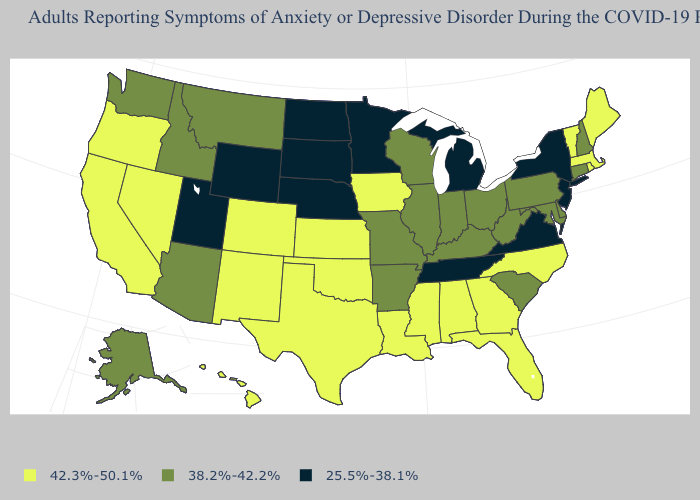What is the value of Ohio?
Quick response, please. 38.2%-42.2%. Does Delaware have the highest value in the USA?
Answer briefly. No. What is the value of Maryland?
Concise answer only. 38.2%-42.2%. Which states have the lowest value in the West?
Short answer required. Utah, Wyoming. What is the highest value in the USA?
Quick response, please. 42.3%-50.1%. Does New Mexico have the same value as Arizona?
Keep it brief. No. What is the lowest value in the South?
Answer briefly. 25.5%-38.1%. What is the value of New Hampshire?
Quick response, please. 38.2%-42.2%. What is the value of Montana?
Concise answer only. 38.2%-42.2%. Among the states that border Vermont , which have the lowest value?
Give a very brief answer. New York. Does Kansas have a lower value than Nevada?
Write a very short answer. No. Which states have the lowest value in the USA?
Short answer required. Michigan, Minnesota, Nebraska, New Jersey, New York, North Dakota, South Dakota, Tennessee, Utah, Virginia, Wyoming. Name the states that have a value in the range 38.2%-42.2%?
Quick response, please. Alaska, Arizona, Arkansas, Connecticut, Delaware, Idaho, Illinois, Indiana, Kentucky, Maryland, Missouri, Montana, New Hampshire, Ohio, Pennsylvania, South Carolina, Washington, West Virginia, Wisconsin. What is the value of Pennsylvania?
Be succinct. 38.2%-42.2%. Does Colorado have the same value as Alabama?
Concise answer only. Yes. 